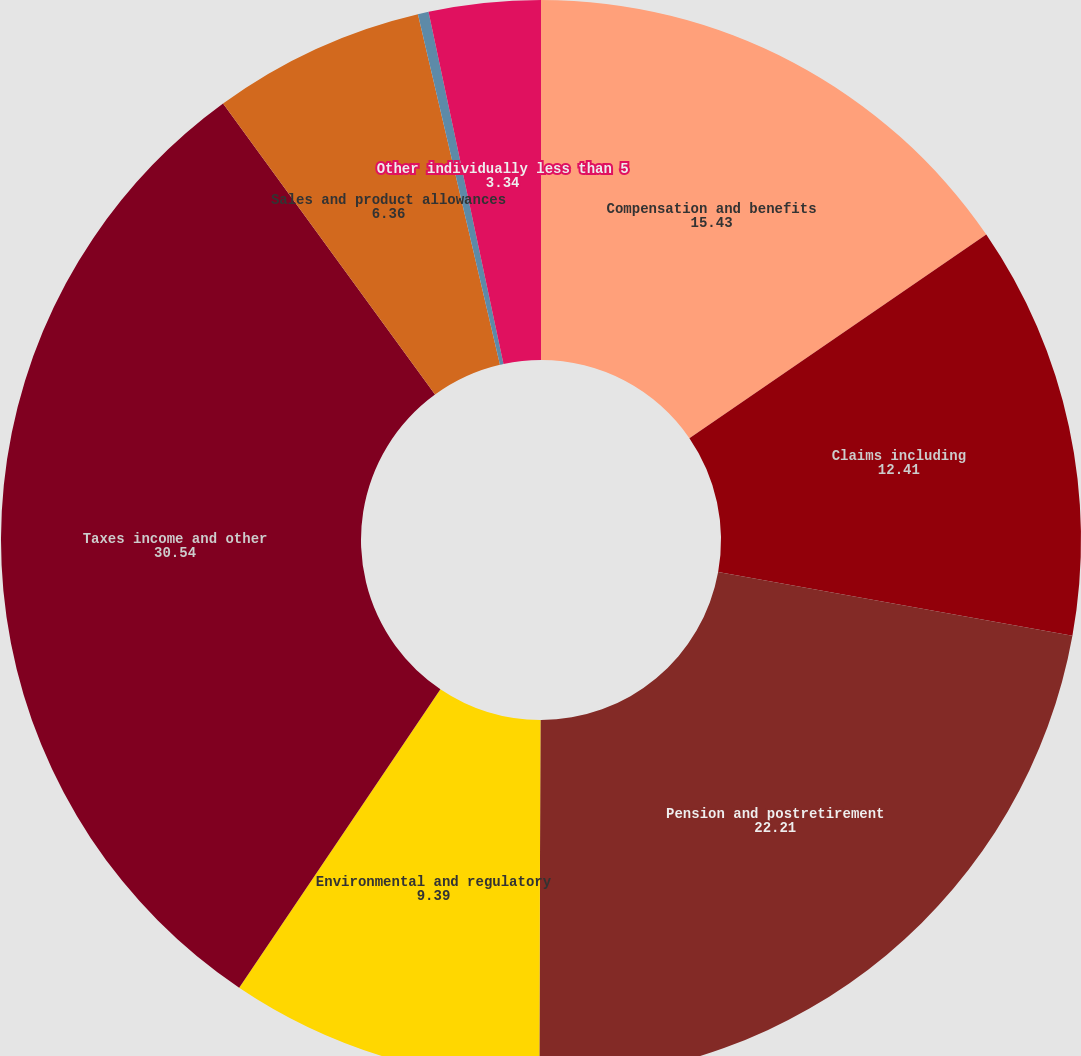Convert chart. <chart><loc_0><loc_0><loc_500><loc_500><pie_chart><fcel>Compensation and benefits<fcel>Claims including<fcel>Pension and postretirement<fcel>Environmental and regulatory<fcel>Taxes income and other<fcel>Sales and product allowances<fcel>Warranty<fcel>Other individually less than 5<nl><fcel>15.43%<fcel>12.41%<fcel>22.21%<fcel>9.39%<fcel>30.54%<fcel>6.36%<fcel>0.32%<fcel>3.34%<nl></chart> 